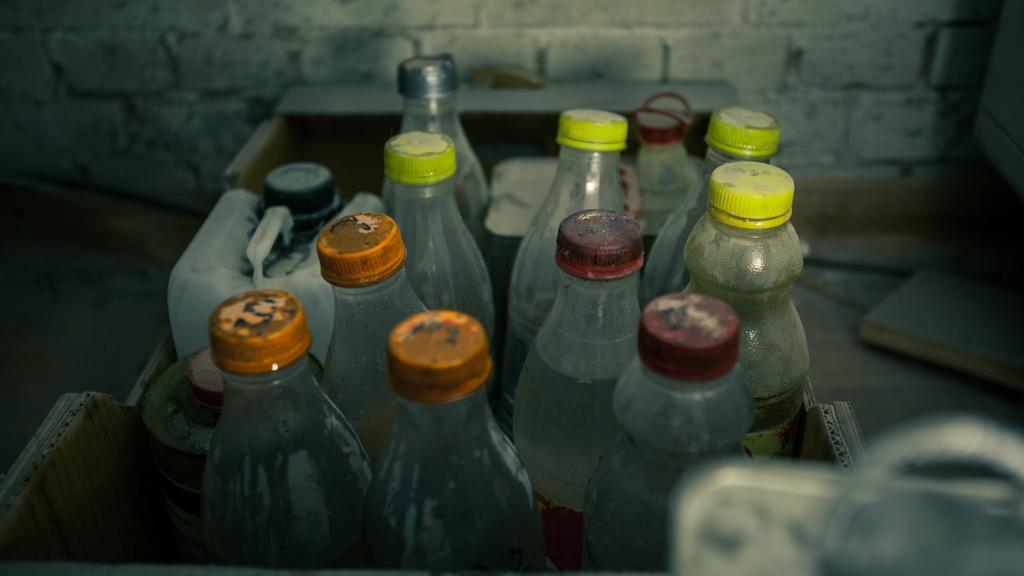How would you summarize this image in a sentence or two? In this picture there are some bottles and a cans which are placed in the basket. In the background there is a wall. 